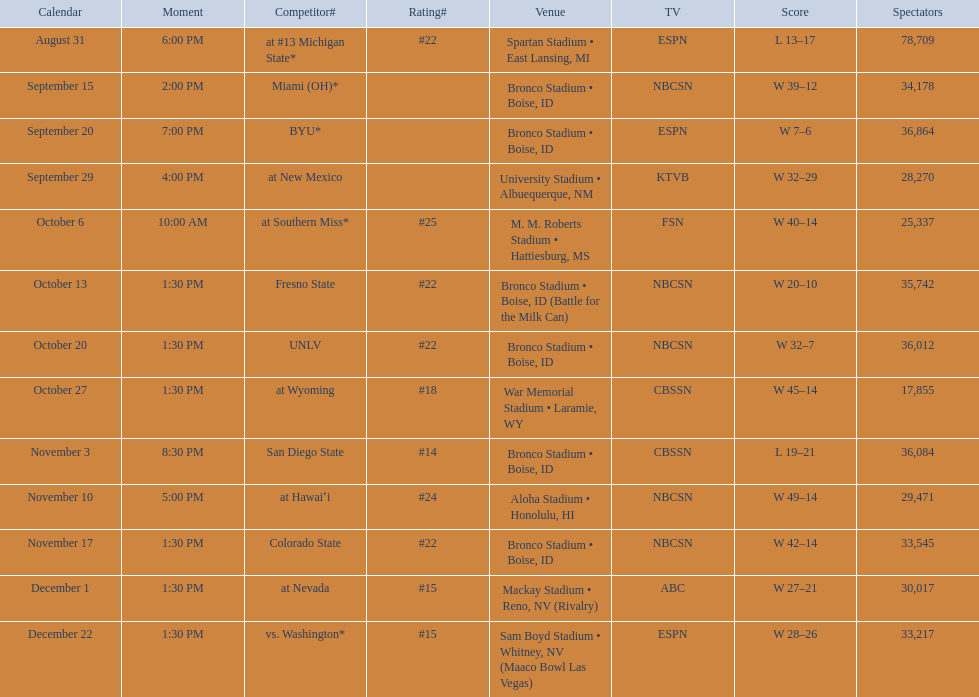Add up the total number of points scored in the last wins for boise state. 146. 